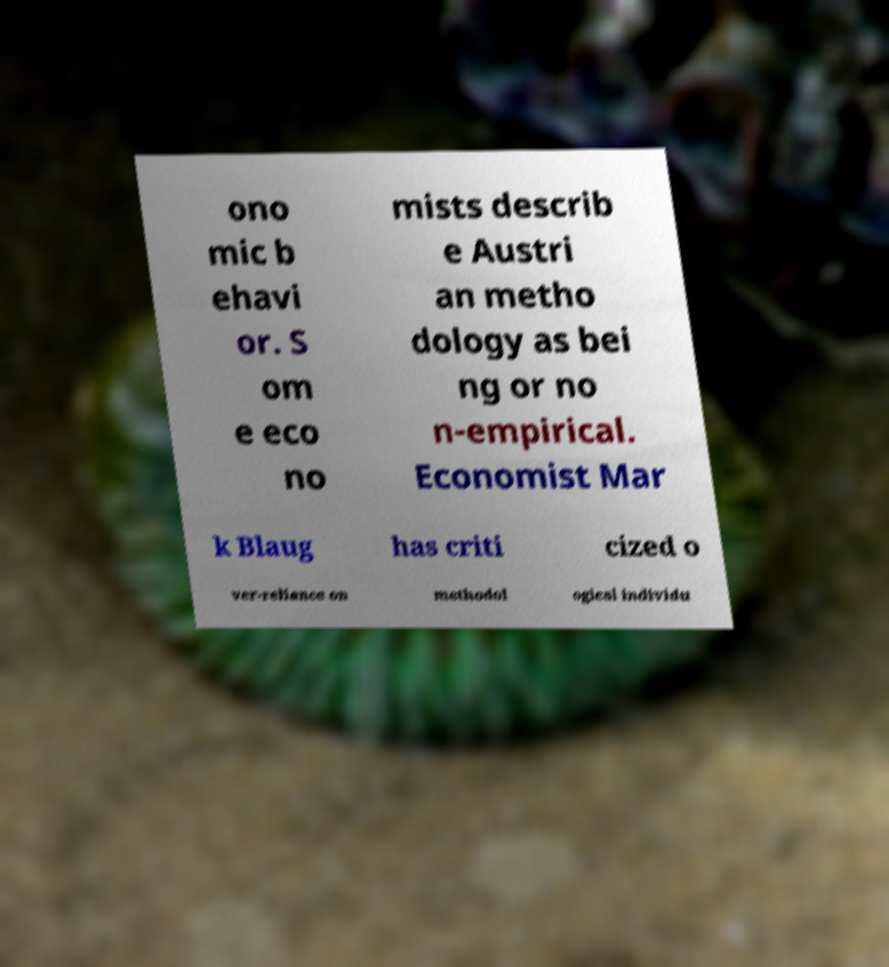Please identify and transcribe the text found in this image. ono mic b ehavi or. S om e eco no mists describ e Austri an metho dology as bei ng or no n-empirical. Economist Mar k Blaug has criti cized o ver-reliance on methodol ogical individu 